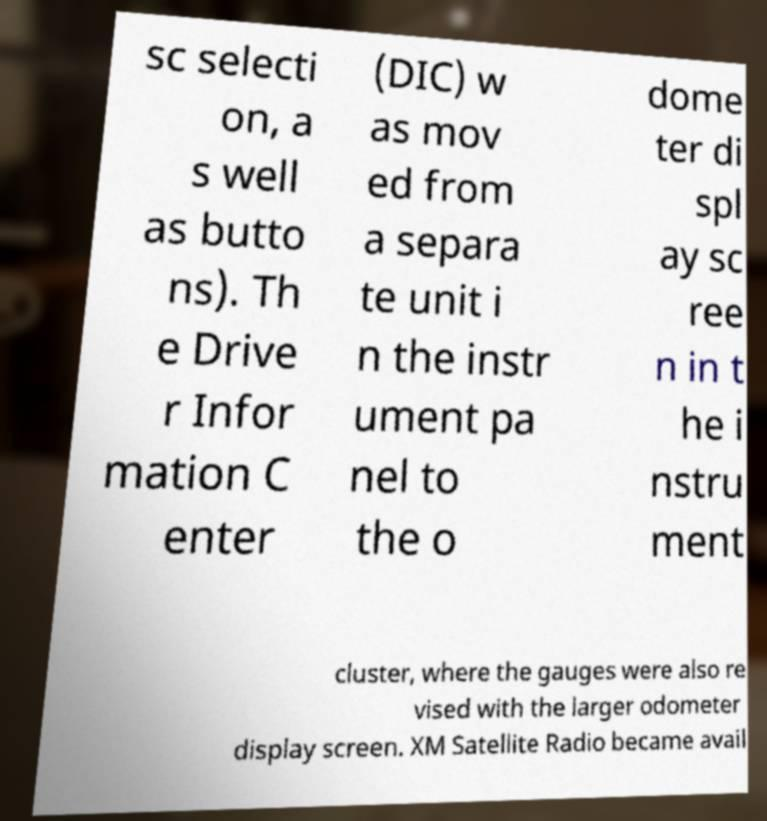There's text embedded in this image that I need extracted. Can you transcribe it verbatim? sc selecti on, a s well as butto ns). Th e Drive r Infor mation C enter (DIC) w as mov ed from a separa te unit i n the instr ument pa nel to the o dome ter di spl ay sc ree n in t he i nstru ment cluster, where the gauges were also re vised with the larger odometer display screen. XM Satellite Radio became avail 